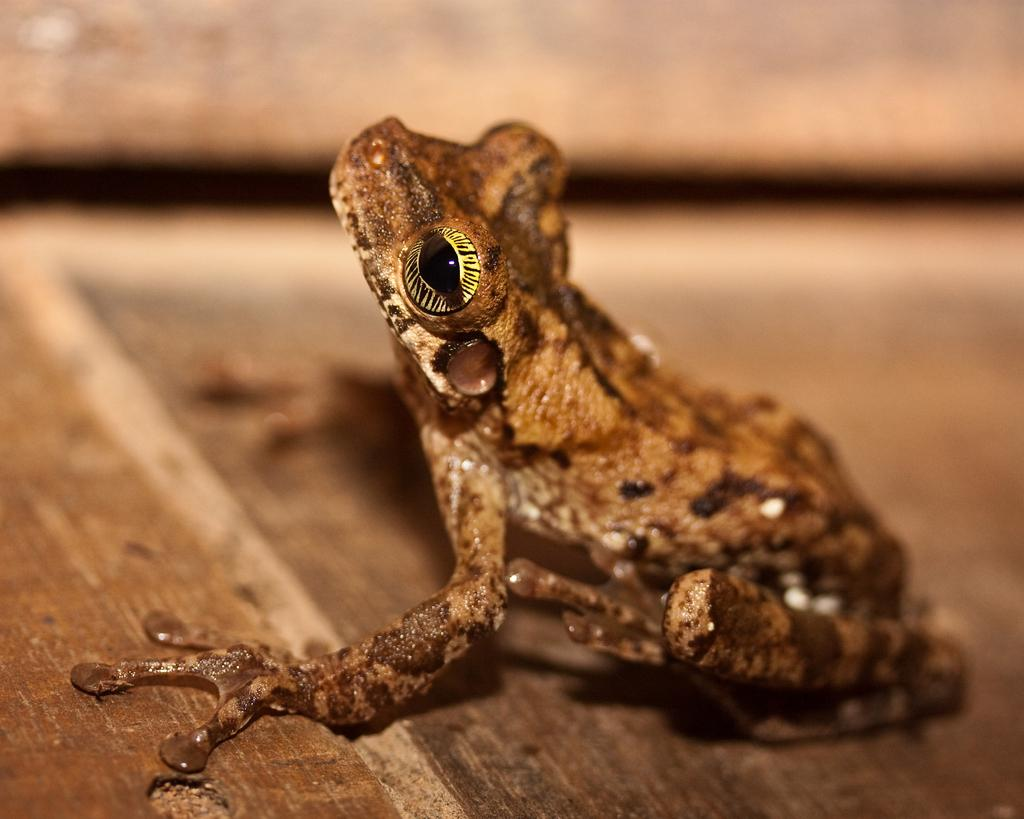What animal is present in the image? There is a frog in the image. Where is the frog located in the image? The frog is on the floor. How many clocks can be seen hanging from the twig in the image? There are no clocks or twigs present in the image; it only features a frog on the floor. 